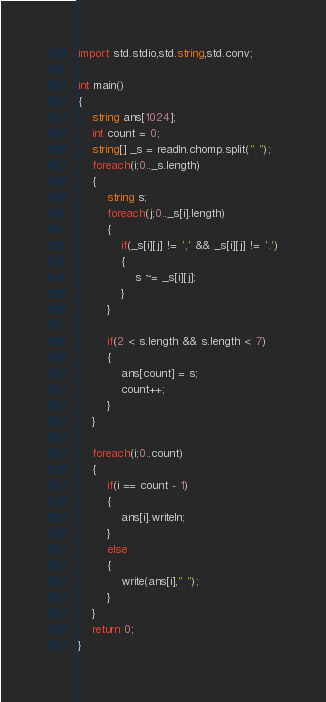Convert code to text. <code><loc_0><loc_0><loc_500><loc_500><_D_>import std.stdio,std.string,std.conv;

int main()
{
	string ans[1024];
	int count = 0;
	string[] _s = readln.chomp.split(" ");
	foreach(i;0.._s.length)
	{
		string s;
		foreach(j;0.._s[i].length)
		{
			if(_s[i][j] != ',' && _s[i][j] != '.')
			{
				s ~= _s[i][j];
			}
		}

		if(2 < s.length && s.length < 7)
		{
			ans[count] = s;
			count++;
		}
	}

	foreach(i;0..count)
	{
		if(i == count - 1)
		{
			ans[i].writeln;
		}
		else
		{
			write(ans[i]," ");
		}
	}
	return 0;
}</code> 